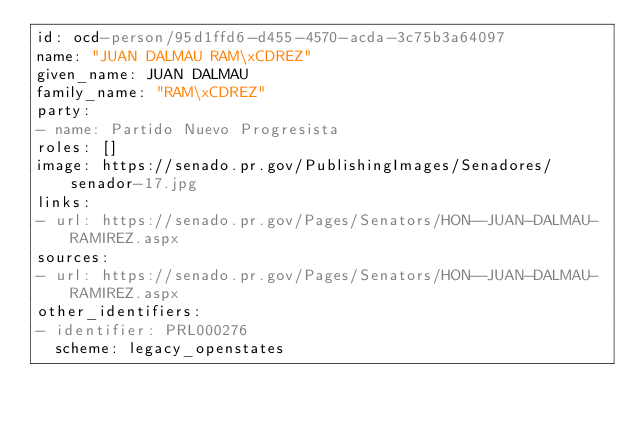<code> <loc_0><loc_0><loc_500><loc_500><_YAML_>id: ocd-person/95d1ffd6-d455-4570-acda-3c75b3a64097
name: "JUAN DALMAU RAM\xCDREZ"
given_name: JUAN DALMAU
family_name: "RAM\xCDREZ"
party:
- name: Partido Nuevo Progresista
roles: []
image: https://senado.pr.gov/PublishingImages/Senadores/senador-17.jpg
links:
- url: https://senado.pr.gov/Pages/Senators/HON--JUAN-DALMAU-RAMIREZ.aspx
sources:
- url: https://senado.pr.gov/Pages/Senators/HON--JUAN-DALMAU-RAMIREZ.aspx
other_identifiers:
- identifier: PRL000276
  scheme: legacy_openstates
</code> 